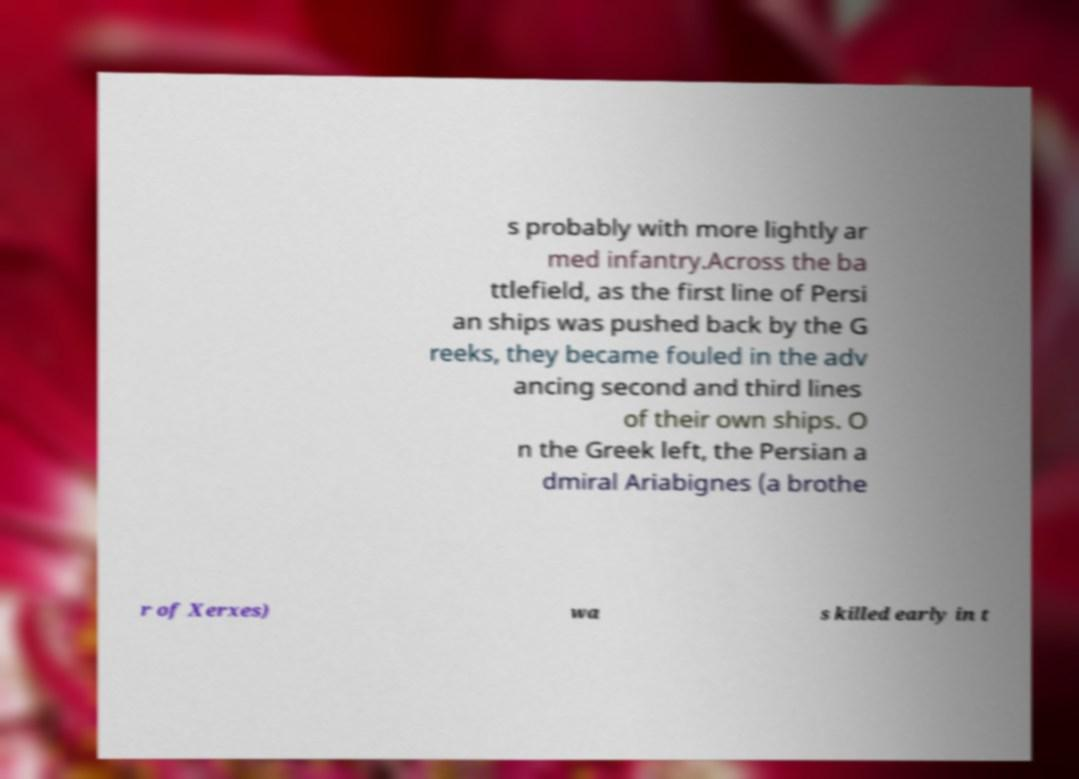What messages or text are displayed in this image? I need them in a readable, typed format. s probably with more lightly ar med infantry.Across the ba ttlefield, as the first line of Persi an ships was pushed back by the G reeks, they became fouled in the adv ancing second and third lines of their own ships. O n the Greek left, the Persian a dmiral Ariabignes (a brothe r of Xerxes) wa s killed early in t 